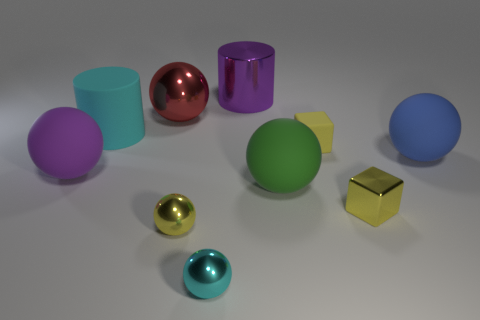How many yellow blocks must be subtracted to get 1 yellow blocks? 1 Subtract all large purple matte spheres. How many spheres are left? 5 Subtract all blocks. How many objects are left? 8 Subtract all yellow metallic cubes. Subtract all large green matte things. How many objects are left? 8 Add 7 large purple matte things. How many large purple matte things are left? 8 Add 5 tiny yellow shiny balls. How many tiny yellow shiny balls exist? 6 Subtract all cyan spheres. How many spheres are left? 5 Subtract 1 red balls. How many objects are left? 9 Subtract 4 balls. How many balls are left? 2 Subtract all purple spheres. Subtract all purple blocks. How many spheres are left? 5 